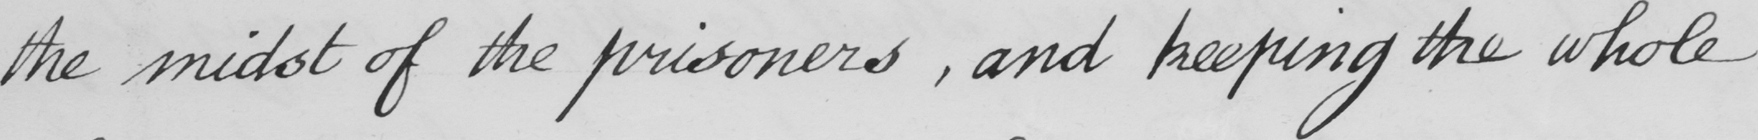What text is written in this handwritten line? the midst of the prisoners  , and keeping the whole 